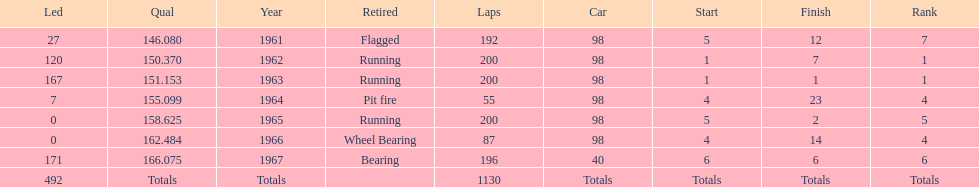What car achieved the highest qual? 40. 